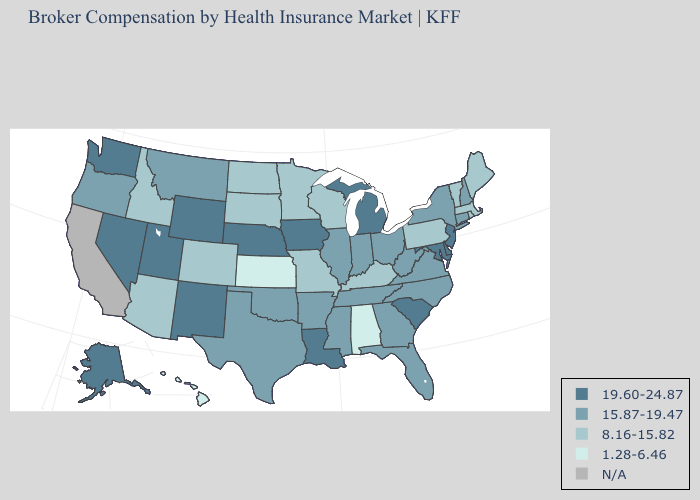Does the first symbol in the legend represent the smallest category?
Answer briefly. No. Among the states that border Kentucky , does Missouri have the lowest value?
Concise answer only. Yes. What is the lowest value in states that border New Mexico?
Be succinct. 8.16-15.82. Does New York have the lowest value in the Northeast?
Concise answer only. No. Name the states that have a value in the range N/A?
Keep it brief. California. Name the states that have a value in the range N/A?
Be succinct. California. Which states have the lowest value in the USA?
Be succinct. Alabama, Hawaii, Kansas. Does Wisconsin have the lowest value in the USA?
Concise answer only. No. Does Rhode Island have the highest value in the USA?
Quick response, please. No. Name the states that have a value in the range 1.28-6.46?
Short answer required. Alabama, Hawaii, Kansas. Does the map have missing data?
Short answer required. Yes. Among the states that border New York , does Connecticut have the lowest value?
Answer briefly. No. What is the highest value in the USA?
Be succinct. 19.60-24.87. What is the highest value in the USA?
Keep it brief. 19.60-24.87. 